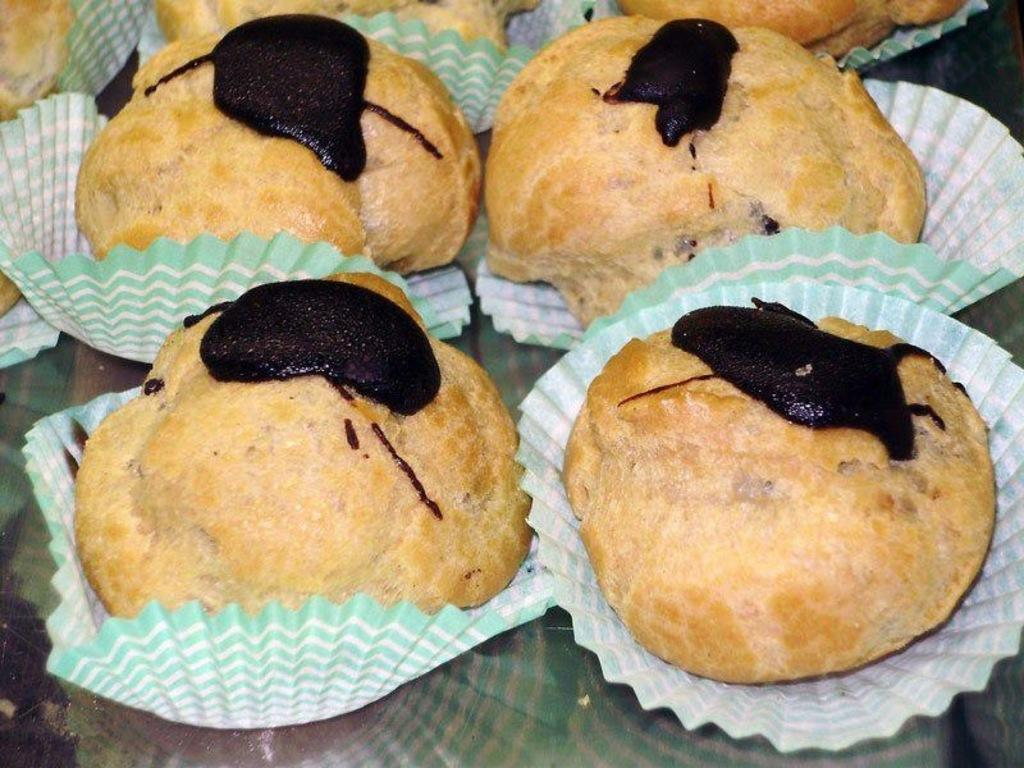What is placed on the table in the image? There are snacks placed on a table in the image. What type of fish can be seen swimming in the brain of the person in the image? There is no person or fish present in the image; it only shows snacks placed on a table. 